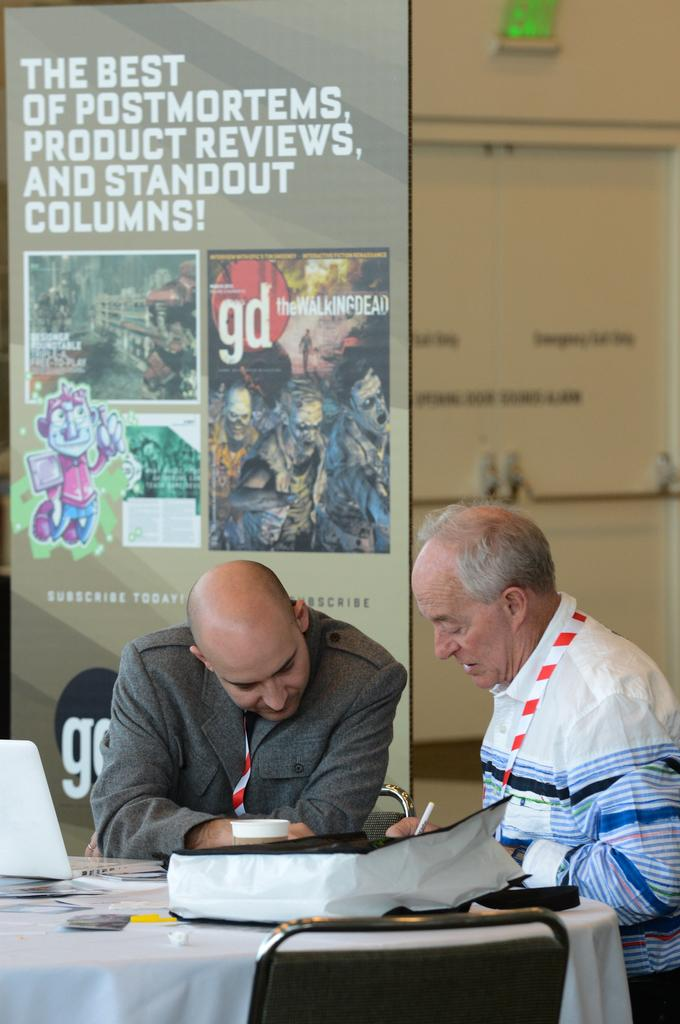<image>
Share a concise interpretation of the image provided. Two men are at a table with a sign in the background that says The Best of Postmortems, Product Reviews, and Standout Columns. 